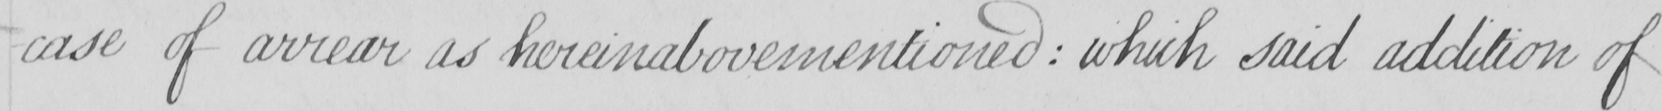Can you tell me what this handwritten text says? case of arrear as hereinabovementioned  :  which said addition of 